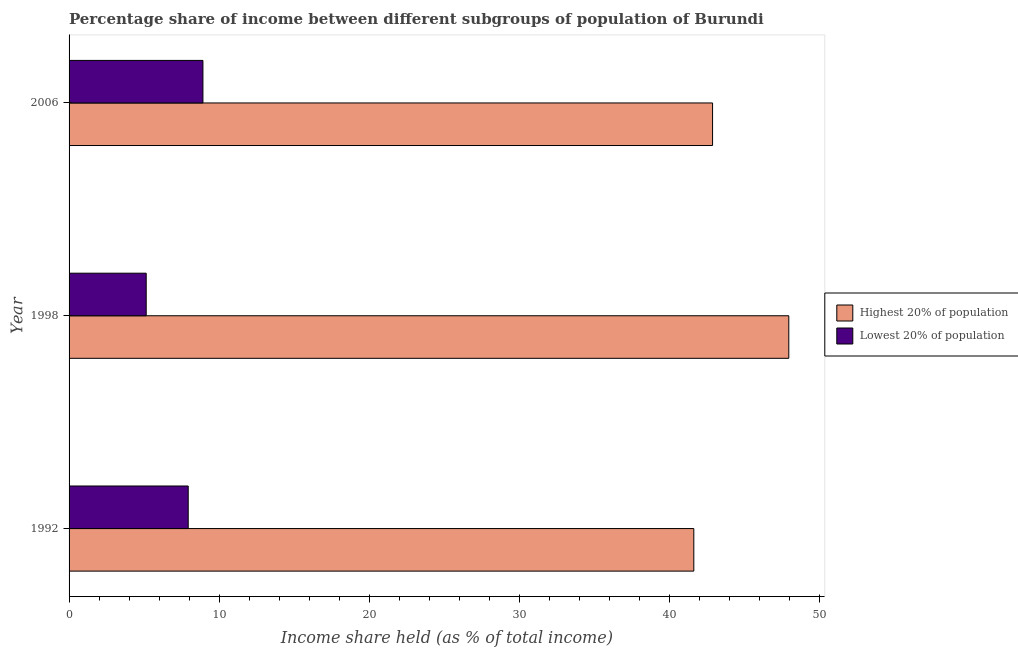How many different coloured bars are there?
Your answer should be compact. 2. Are the number of bars per tick equal to the number of legend labels?
Provide a short and direct response. Yes. What is the label of the 2nd group of bars from the top?
Ensure brevity in your answer.  1998. In how many cases, is the number of bars for a given year not equal to the number of legend labels?
Make the answer very short. 0. What is the income share held by highest 20% of the population in 2006?
Your answer should be very brief. 42.88. Across all years, what is the maximum income share held by lowest 20% of the population?
Provide a short and direct response. 8.92. Across all years, what is the minimum income share held by lowest 20% of the population?
Provide a short and direct response. 5.14. In which year was the income share held by highest 20% of the population maximum?
Your response must be concise. 1998. In which year was the income share held by lowest 20% of the population minimum?
Your response must be concise. 1998. What is the difference between the income share held by lowest 20% of the population in 1998 and the income share held by highest 20% of the population in 1992?
Give a very brief answer. -36.49. What is the average income share held by lowest 20% of the population per year?
Your answer should be compact. 7.33. In the year 1998, what is the difference between the income share held by lowest 20% of the population and income share held by highest 20% of the population?
Your answer should be compact. -42.82. In how many years, is the income share held by lowest 20% of the population greater than 4 %?
Offer a very short reply. 3. What is the difference between the highest and the second highest income share held by highest 20% of the population?
Your answer should be compact. 5.08. What is the difference between the highest and the lowest income share held by lowest 20% of the population?
Make the answer very short. 3.78. In how many years, is the income share held by lowest 20% of the population greater than the average income share held by lowest 20% of the population taken over all years?
Provide a short and direct response. 2. Is the sum of the income share held by highest 20% of the population in 1992 and 1998 greater than the maximum income share held by lowest 20% of the population across all years?
Give a very brief answer. Yes. What does the 1st bar from the top in 2006 represents?
Your answer should be compact. Lowest 20% of population. What does the 1st bar from the bottom in 1992 represents?
Ensure brevity in your answer.  Highest 20% of population. How many bars are there?
Make the answer very short. 6. How many years are there in the graph?
Give a very brief answer. 3. Does the graph contain any zero values?
Ensure brevity in your answer.  No. How many legend labels are there?
Keep it short and to the point. 2. How are the legend labels stacked?
Ensure brevity in your answer.  Vertical. What is the title of the graph?
Offer a terse response. Percentage share of income between different subgroups of population of Burundi. Does "Age 65(male)" appear as one of the legend labels in the graph?
Keep it short and to the point. No. What is the label or title of the X-axis?
Your response must be concise. Income share held (as % of total income). What is the Income share held (as % of total income) in Highest 20% of population in 1992?
Offer a very short reply. 41.63. What is the Income share held (as % of total income) in Lowest 20% of population in 1992?
Give a very brief answer. 7.94. What is the Income share held (as % of total income) in Highest 20% of population in 1998?
Your response must be concise. 47.96. What is the Income share held (as % of total income) of Lowest 20% of population in 1998?
Your answer should be very brief. 5.14. What is the Income share held (as % of total income) in Highest 20% of population in 2006?
Give a very brief answer. 42.88. What is the Income share held (as % of total income) in Lowest 20% of population in 2006?
Your answer should be compact. 8.92. Across all years, what is the maximum Income share held (as % of total income) in Highest 20% of population?
Ensure brevity in your answer.  47.96. Across all years, what is the maximum Income share held (as % of total income) of Lowest 20% of population?
Keep it short and to the point. 8.92. Across all years, what is the minimum Income share held (as % of total income) in Highest 20% of population?
Give a very brief answer. 41.63. Across all years, what is the minimum Income share held (as % of total income) of Lowest 20% of population?
Offer a very short reply. 5.14. What is the total Income share held (as % of total income) in Highest 20% of population in the graph?
Offer a terse response. 132.47. What is the difference between the Income share held (as % of total income) in Highest 20% of population in 1992 and that in 1998?
Your response must be concise. -6.33. What is the difference between the Income share held (as % of total income) in Highest 20% of population in 1992 and that in 2006?
Your response must be concise. -1.25. What is the difference between the Income share held (as % of total income) in Lowest 20% of population in 1992 and that in 2006?
Offer a very short reply. -0.98. What is the difference between the Income share held (as % of total income) in Highest 20% of population in 1998 and that in 2006?
Give a very brief answer. 5.08. What is the difference between the Income share held (as % of total income) in Lowest 20% of population in 1998 and that in 2006?
Keep it short and to the point. -3.78. What is the difference between the Income share held (as % of total income) of Highest 20% of population in 1992 and the Income share held (as % of total income) of Lowest 20% of population in 1998?
Give a very brief answer. 36.49. What is the difference between the Income share held (as % of total income) in Highest 20% of population in 1992 and the Income share held (as % of total income) in Lowest 20% of population in 2006?
Offer a terse response. 32.71. What is the difference between the Income share held (as % of total income) of Highest 20% of population in 1998 and the Income share held (as % of total income) of Lowest 20% of population in 2006?
Your answer should be compact. 39.04. What is the average Income share held (as % of total income) in Highest 20% of population per year?
Your answer should be compact. 44.16. What is the average Income share held (as % of total income) in Lowest 20% of population per year?
Your answer should be compact. 7.33. In the year 1992, what is the difference between the Income share held (as % of total income) in Highest 20% of population and Income share held (as % of total income) in Lowest 20% of population?
Your response must be concise. 33.69. In the year 1998, what is the difference between the Income share held (as % of total income) in Highest 20% of population and Income share held (as % of total income) in Lowest 20% of population?
Your answer should be compact. 42.82. In the year 2006, what is the difference between the Income share held (as % of total income) of Highest 20% of population and Income share held (as % of total income) of Lowest 20% of population?
Provide a short and direct response. 33.96. What is the ratio of the Income share held (as % of total income) in Highest 20% of population in 1992 to that in 1998?
Provide a short and direct response. 0.87. What is the ratio of the Income share held (as % of total income) of Lowest 20% of population in 1992 to that in 1998?
Your answer should be compact. 1.54. What is the ratio of the Income share held (as % of total income) in Highest 20% of population in 1992 to that in 2006?
Give a very brief answer. 0.97. What is the ratio of the Income share held (as % of total income) in Lowest 20% of population in 1992 to that in 2006?
Keep it short and to the point. 0.89. What is the ratio of the Income share held (as % of total income) of Highest 20% of population in 1998 to that in 2006?
Provide a succinct answer. 1.12. What is the ratio of the Income share held (as % of total income) of Lowest 20% of population in 1998 to that in 2006?
Give a very brief answer. 0.58. What is the difference between the highest and the second highest Income share held (as % of total income) of Highest 20% of population?
Keep it short and to the point. 5.08. What is the difference between the highest and the lowest Income share held (as % of total income) in Highest 20% of population?
Offer a very short reply. 6.33. What is the difference between the highest and the lowest Income share held (as % of total income) of Lowest 20% of population?
Provide a succinct answer. 3.78. 